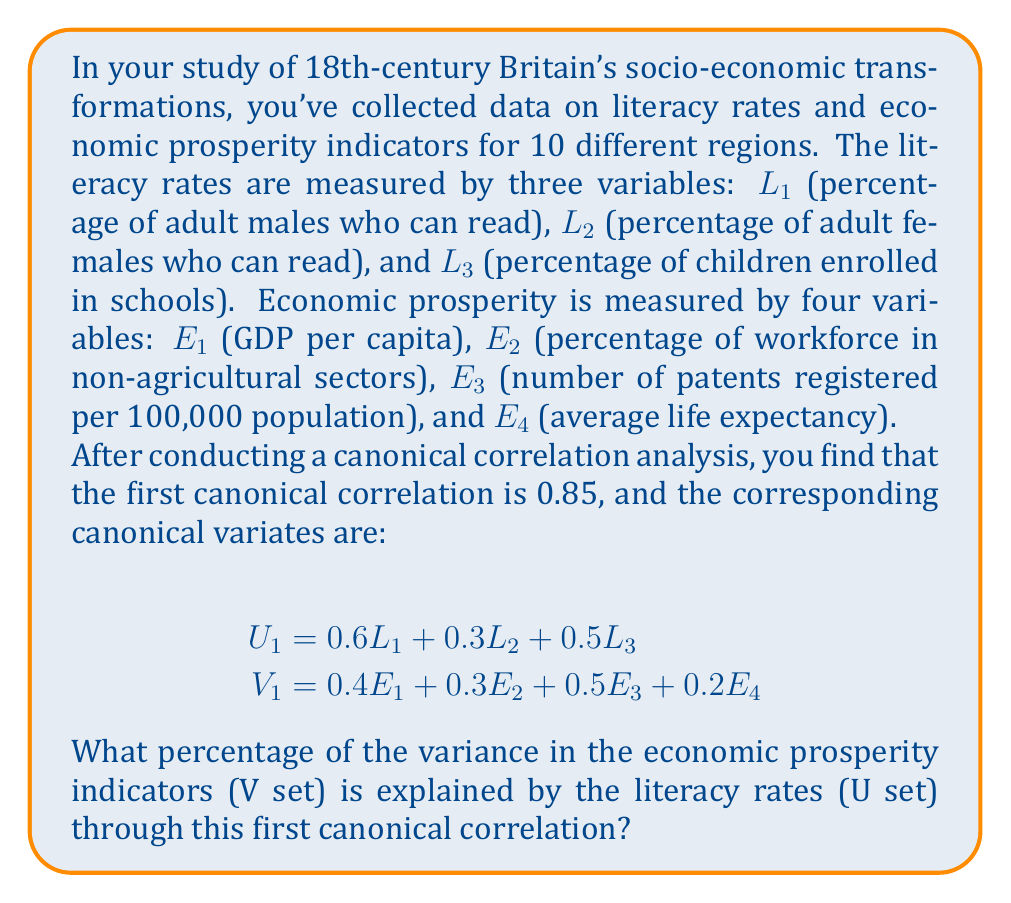Teach me how to tackle this problem. To solve this problem, we need to follow these steps:

1) Recall that the squared canonical correlation ($r_c^2$) represents the amount of variance shared by the canonical variates.

2) The first canonical correlation is given as 0.85, so we need to square this value:

   $r_c^2 = 0.85^2 = 0.7225$

3) This means that 72.25% of the variance is shared between the first pair of canonical variates ($U_1$ and $V_1$).

4) However, the question asks about the variance in the economic prosperity indicators (V set) explained by the literacy rates (U set).

5) To find this, we need to calculate the average squared canonical loading for the V set. The canonical loadings are the correlations between the original variables and their canonical variates.

6) Given the canonical variate for V:

   $V_1 = 0.4E_1 + 0.3E_2 + 0.5E_3 + 0.2E_4$

   These coefficients can be considered approximations of the canonical loadings.

7) We square each of these loadings and take the average:

   $\frac{(0.4^2 + 0.3^2 + 0.5^2 + 0.2^2)}{4} = \frac{0.16 + 0.09 + 0.25 + 0.04}{4} = \frac{0.54}{4} = 0.135$

8) Finally, we multiply this average by the squared canonical correlation:

   $0.135 * 0.7225 = 0.09754 \approx 0.0975$

9) Convert to a percentage: 0.0975 * 100 = 9.75%

Therefore, approximately 9.75% of the variance in the economic prosperity indicators is explained by the literacy rates through the first canonical correlation.
Answer: 9.75% 